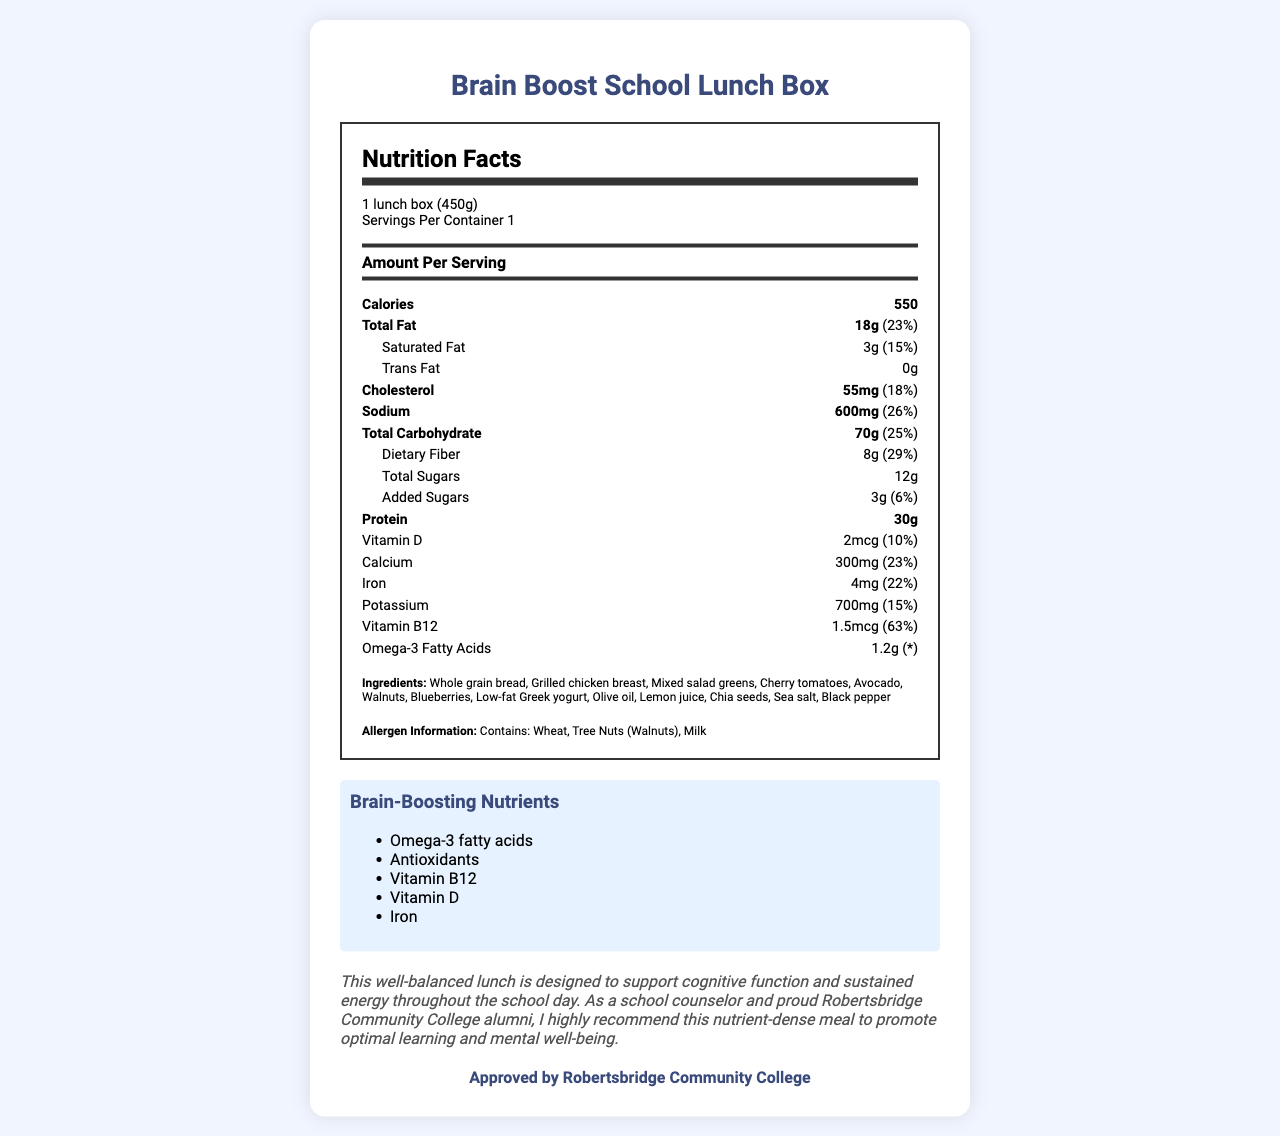What is the serving size for the Brain Boost School Lunch Box? The serving size is specified as "1 lunch box (450g)" in the document.
Answer: 1 lunch box (450g) How many calories are in one serving of the Brain Boost School Lunch Box? The document states the calorie content as 550.
Answer: 550 What percentage of the daily value for iron does the Brain Boost School Lunch Box provide? The document states that the iron content is 4mg, which is 22% of the daily value.
Answer: 22% What are the total fats and the percentage of daily value provided by the Brain Boost School Lunch Box? The total fat content is 18g, which is 23% of the daily value as per the document.
Answer: 18g, 23% Can you list three ingredients of the Brain Boost School Lunch Box? The ingredients section lists these among others.
Answer: Whole grain bread, Grilled chicken breast, Mixed salad greens Which of the following nutrients are classified as brain-boosting in the Brain Boost School Lunch Box? A. Vitamin C B. Omega-3 fatty acids C. Zinc D. Antioxidants The brain-boosting nutrients listed in the document include Omega-3 fatty acids and Antioxidants.
Answer: B and D Which nutrient has the highest daily value percentage in the Brain Boost School Lunch Box? A. Vitamin D B. Iron C. Vitamin B12 D. Potassium Vitamin B12 has the highest daily value percentage at 63%.
Answer: C. Vitamin B12 Does the Brain Boost School Lunch Box contain any added sugars? The document lists an amount of 3g of added sugars.
Answer: Yes Is the Brain Boost School Lunch Box approved by Robertsbridge Community College? The document states it is approved by Robertsbridge Community College.
Answer: Yes Summarize the main idea of the Brain Boost School Lunch Box document. The document highlights the nutritional benefits, lists brain-boosting nutrients, ingredients, and includes a counselor's note promoting the meal's cognitive benefits.
Answer: The Brain Boost School Lunch Box provides a balanced meal designed to support cognitive function and sustained energy. It features detailed nutrition information, brain-boosting nutrients, ingredients, allergen information, and an endorsement from Robertsbridge Community College. What is the source of Vitamin C in the Brain Boost School Lunch Box? The document does not provide details on Vitamin C content or sources.
Answer: Not enough information 